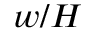Convert formula to latex. <formula><loc_0><loc_0><loc_500><loc_500>w / H</formula> 